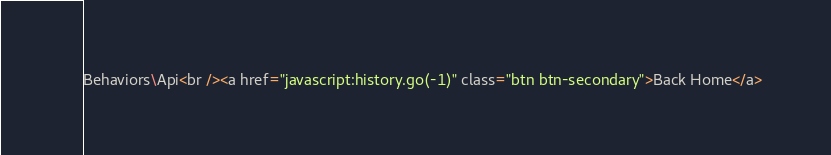<code> <loc_0><loc_0><loc_500><loc_500><_C#_>Behaviors\Api<br /><a href="javascript:history.go(-1)" class="btn btn-secondary">Back Home</a></code> 